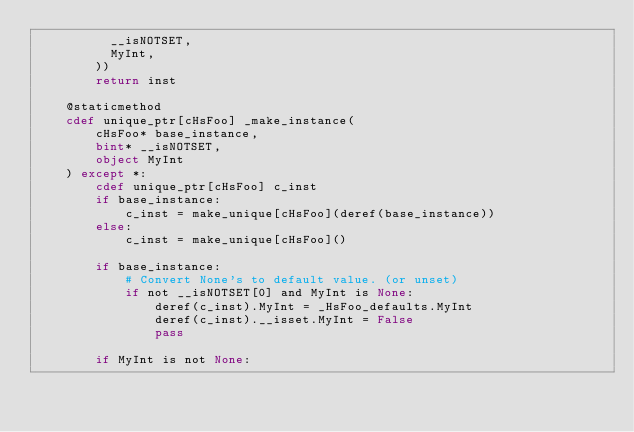Convert code to text. <code><loc_0><loc_0><loc_500><loc_500><_Cython_>          __isNOTSET,
          MyInt,
        ))
        return inst

    @staticmethod
    cdef unique_ptr[cHsFoo] _make_instance(
        cHsFoo* base_instance,
        bint* __isNOTSET,
        object MyInt 
    ) except *:
        cdef unique_ptr[cHsFoo] c_inst
        if base_instance:
            c_inst = make_unique[cHsFoo](deref(base_instance))
        else:
            c_inst = make_unique[cHsFoo]()

        if base_instance:
            # Convert None's to default value. (or unset)
            if not __isNOTSET[0] and MyInt is None:
                deref(c_inst).MyInt = _HsFoo_defaults.MyInt
                deref(c_inst).__isset.MyInt = False
                pass

        if MyInt is not None:</code> 